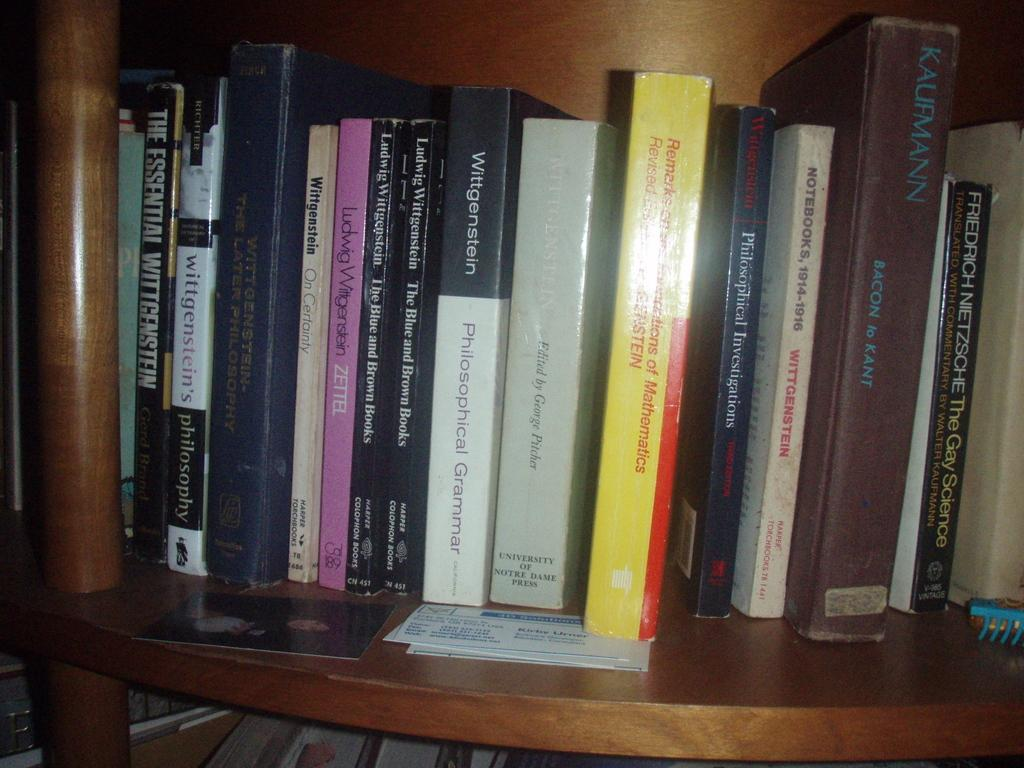Provide a one-sentence caption for the provided image. Several philosophy books sit together on a shelf. 